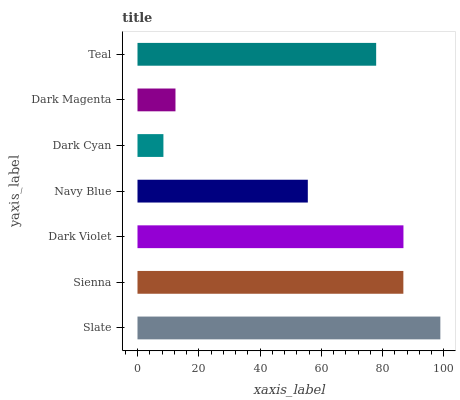Is Dark Cyan the minimum?
Answer yes or no. Yes. Is Slate the maximum?
Answer yes or no. Yes. Is Sienna the minimum?
Answer yes or no. No. Is Sienna the maximum?
Answer yes or no. No. Is Slate greater than Sienna?
Answer yes or no. Yes. Is Sienna less than Slate?
Answer yes or no. Yes. Is Sienna greater than Slate?
Answer yes or no. No. Is Slate less than Sienna?
Answer yes or no. No. Is Teal the high median?
Answer yes or no. Yes. Is Teal the low median?
Answer yes or no. Yes. Is Slate the high median?
Answer yes or no. No. Is Sienna the low median?
Answer yes or no. No. 